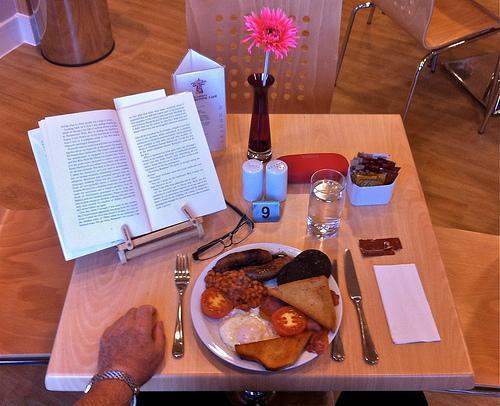How many books are on the table?
Give a very brief answer. 1. How many objects are fully on the right side of the plate?
Give a very brief answer. 5. 